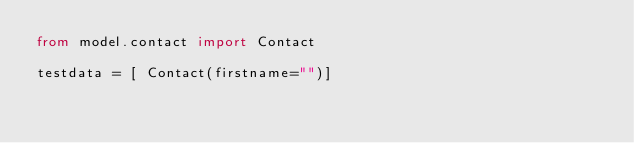Convert code to text. <code><loc_0><loc_0><loc_500><loc_500><_Python_>from model.contact import Contact

testdata = [ Contact(firstname="")]</code> 